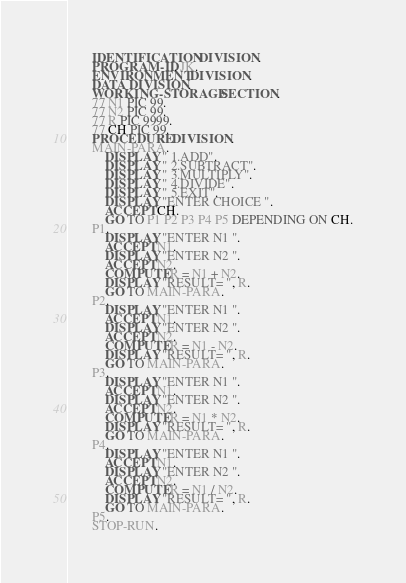Convert code to text. <code><loc_0><loc_0><loc_500><loc_500><_COBOL_>       IDENTIFICATION DIVISION.
       PROGRAM-ID. JK.
       ENVIRONMENT DIVISION.
       DATA DIVISION.
       WORKING-STORAGE SECTION.
       77 N1 PIC 99.
       77 N2 PIC 99.
       77 R PIC 9999.
       77 CH PIC 99.
       PROCEDURE DIVISION.
       MAIN-PARA.
           DISPLAY " 1.ADD".
           DISPLAY " 2.SUBTRACT".
           DISPLAY " 3.MULTIPLY".
           DISPLAY " 4.DIVIDE".
           DISPLAY " 5.EXIT".
           DISPLAY "ENTER CHOICE ".
           ACCEPT CH.
           GO TO P1 P2 P3 P4 P5 DEPENDING ON CH.
       P1.
           DISPLAY "ENTER N1 ".
           ACCEPT N1.
           DISPLAY "ENTER N2 ".
           ACCEPT N2.
           COMPUTE R = N1 + N2.
           DISPLAY "RESULT= ", R.
           GO TO MAIN-PARA.
       P2.
           DISPLAY "ENTER N1 ".
           ACCEPT N1.
           DISPLAY "ENTER N2 ".
           ACCEPT N2.
           COMPUTE R = N1 - N2.
           DISPLAY "RESULT= ", R.
           GO TO MAIN-PARA.
       P3.
           DISPLAY "ENTER N1 ".
           ACCEPT N1.
           DISPLAY "ENTER N2 ".
           ACCEPT N2.
           COMPUTE R = N1 * N2.
           DISPLAY "RESULT= ", R.
           GO TO MAIN-PARA.
       P4.
           DISPLAY "ENTER N1 ".
           ACCEPT N1.
           DISPLAY "ENTER N2 ".
           ACCEPT N2.
           COMPUTE R = N1 / N2.
           DISPLAY "RESULT= ", R.
           GO TO MAIN-PARA.
       P5.
       STOP-RUN.
</code> 